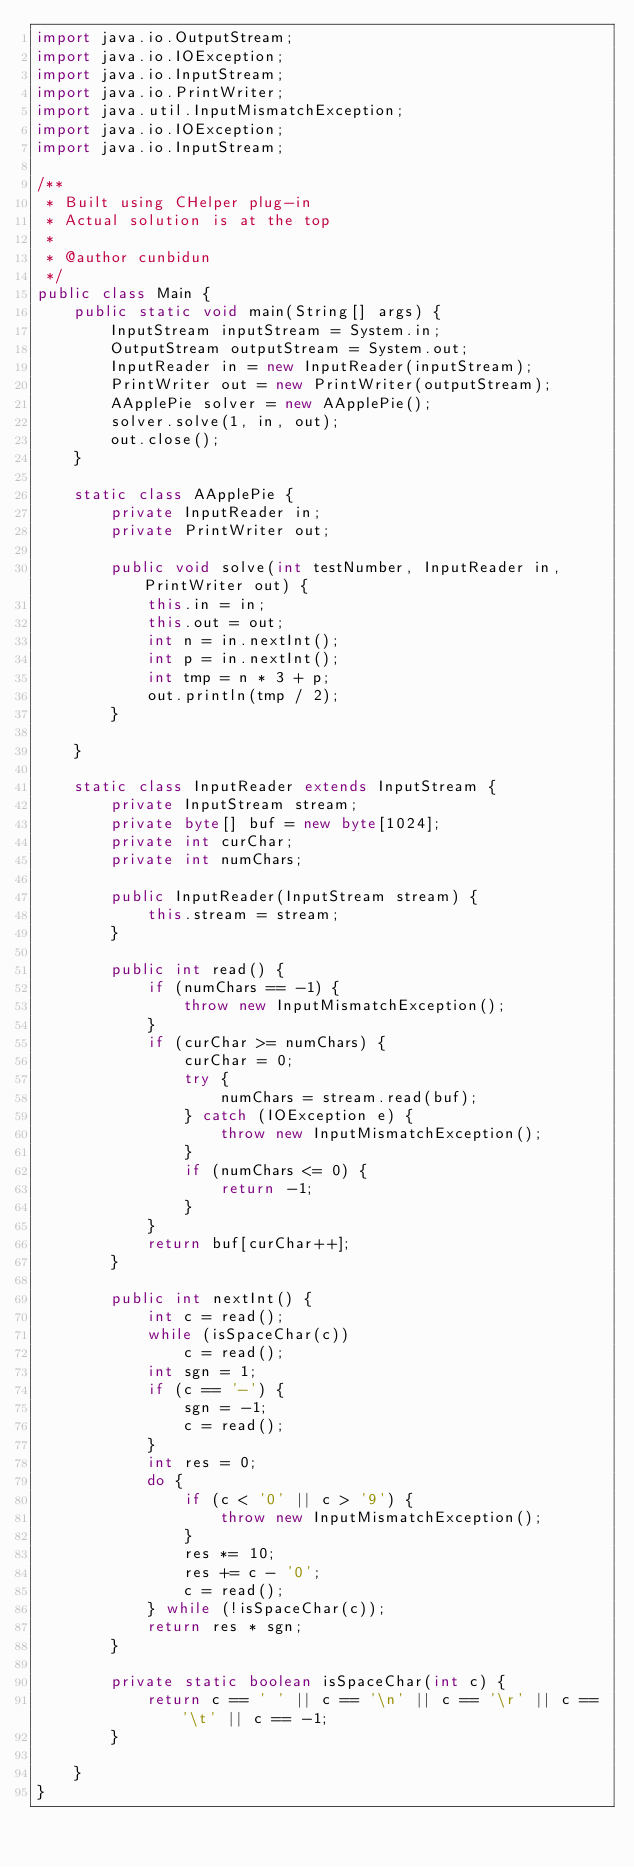<code> <loc_0><loc_0><loc_500><loc_500><_Java_>import java.io.OutputStream;
import java.io.IOException;
import java.io.InputStream;
import java.io.PrintWriter;
import java.util.InputMismatchException;
import java.io.IOException;
import java.io.InputStream;

/**
 * Built using CHelper plug-in
 * Actual solution is at the top
 *
 * @author cunbidun
 */
public class Main {
    public static void main(String[] args) {
        InputStream inputStream = System.in;
        OutputStream outputStream = System.out;
        InputReader in = new InputReader(inputStream);
        PrintWriter out = new PrintWriter(outputStream);
        AApplePie solver = new AApplePie();
        solver.solve(1, in, out);
        out.close();
    }

    static class AApplePie {
        private InputReader in;
        private PrintWriter out;

        public void solve(int testNumber, InputReader in, PrintWriter out) {
            this.in = in;
            this.out = out;
            int n = in.nextInt();
            int p = in.nextInt();
            int tmp = n * 3 + p;
            out.println(tmp / 2);
        }

    }

    static class InputReader extends InputStream {
        private InputStream stream;
        private byte[] buf = new byte[1024];
        private int curChar;
        private int numChars;

        public InputReader(InputStream stream) {
            this.stream = stream;
        }

        public int read() {
            if (numChars == -1) {
                throw new InputMismatchException();
            }
            if (curChar >= numChars) {
                curChar = 0;
                try {
                    numChars = stream.read(buf);
                } catch (IOException e) {
                    throw new InputMismatchException();
                }
                if (numChars <= 0) {
                    return -1;
                }
            }
            return buf[curChar++];
        }

        public int nextInt() {
            int c = read();
            while (isSpaceChar(c))
                c = read();
            int sgn = 1;
            if (c == '-') {
                sgn = -1;
                c = read();
            }
            int res = 0;
            do {
                if (c < '0' || c > '9') {
                    throw new InputMismatchException();
                }
                res *= 10;
                res += c - '0';
                c = read();
            } while (!isSpaceChar(c));
            return res * sgn;
        }

        private static boolean isSpaceChar(int c) {
            return c == ' ' || c == '\n' || c == '\r' || c == '\t' || c == -1;
        }

    }
}

</code> 